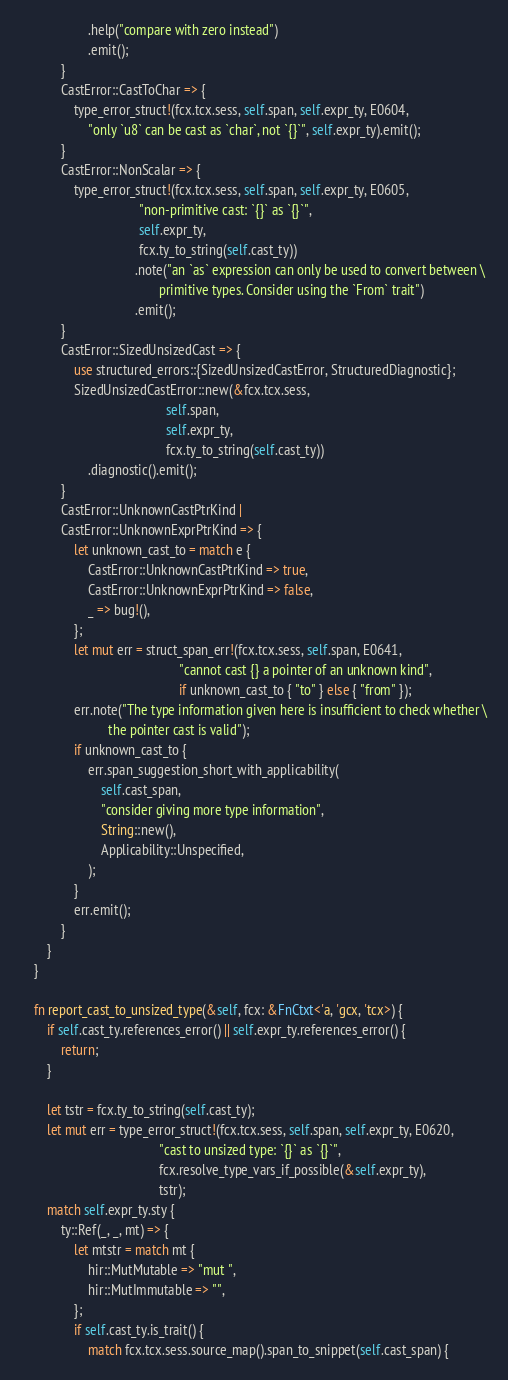<code> <loc_0><loc_0><loc_500><loc_500><_Rust_>                    .help("compare with zero instead")
                    .emit();
            }
            CastError::CastToChar => {
                type_error_struct!(fcx.tcx.sess, self.span, self.expr_ty, E0604,
                    "only `u8` can be cast as `char`, not `{}`", self.expr_ty).emit();
            }
            CastError::NonScalar => {
                type_error_struct!(fcx.tcx.sess, self.span, self.expr_ty, E0605,
                                   "non-primitive cast: `{}` as `{}`",
                                   self.expr_ty,
                                   fcx.ty_to_string(self.cast_ty))
                                  .note("an `as` expression can only be used to convert between \
                                         primitive types. Consider using the `From` trait")
                                  .emit();
            }
            CastError::SizedUnsizedCast => {
                use structured_errors::{SizedUnsizedCastError, StructuredDiagnostic};
                SizedUnsizedCastError::new(&fcx.tcx.sess,
                                           self.span,
                                           self.expr_ty,
                                           fcx.ty_to_string(self.cast_ty))
                    .diagnostic().emit();
            }
            CastError::UnknownCastPtrKind |
            CastError::UnknownExprPtrKind => {
                let unknown_cast_to = match e {
                    CastError::UnknownCastPtrKind => true,
                    CastError::UnknownExprPtrKind => false,
                    _ => bug!(),
                };
                let mut err = struct_span_err!(fcx.tcx.sess, self.span, E0641,
                                               "cannot cast {} a pointer of an unknown kind",
                                               if unknown_cast_to { "to" } else { "from" });
                err.note("The type information given here is insufficient to check whether \
                          the pointer cast is valid");
                if unknown_cast_to {
                    err.span_suggestion_short_with_applicability(
                        self.cast_span,
                        "consider giving more type information",
                        String::new(),
                        Applicability::Unspecified,
                    );
                }
                err.emit();
            }
        }
    }

    fn report_cast_to_unsized_type(&self, fcx: &FnCtxt<'a, 'gcx, 'tcx>) {
        if self.cast_ty.references_error() || self.expr_ty.references_error() {
            return;
        }

        let tstr = fcx.ty_to_string(self.cast_ty);
        let mut err = type_error_struct!(fcx.tcx.sess, self.span, self.expr_ty, E0620,
                                         "cast to unsized type: `{}` as `{}`",
                                         fcx.resolve_type_vars_if_possible(&self.expr_ty),
                                         tstr);
        match self.expr_ty.sty {
            ty::Ref(_, _, mt) => {
                let mtstr = match mt {
                    hir::MutMutable => "mut ",
                    hir::MutImmutable => "",
                };
                if self.cast_ty.is_trait() {
                    match fcx.tcx.sess.source_map().span_to_snippet(self.cast_span) {</code> 